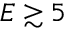<formula> <loc_0><loc_0><loc_500><loc_500>E \gtrsim 5</formula> 